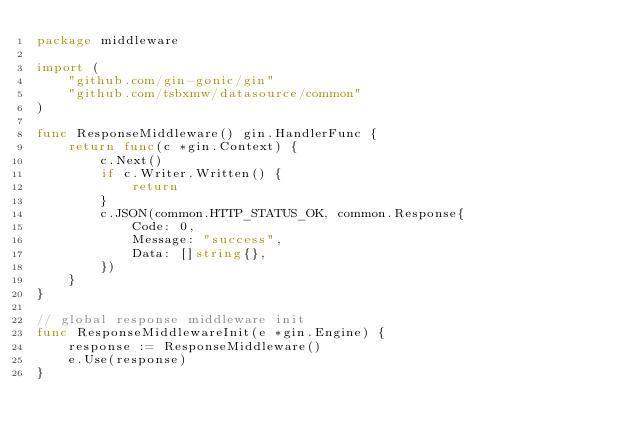Convert code to text. <code><loc_0><loc_0><loc_500><loc_500><_Go_>package middleware

import (
    "github.com/gin-gonic/gin"
    "github.com/tsbxmw/datasource/common"
)

func ResponseMiddleware() gin.HandlerFunc {
    return func(c *gin.Context) {
        c.Next()
        if c.Writer.Written() {
            return
        }
        c.JSON(common.HTTP_STATUS_OK, common.Response{
            Code: 0,
            Message: "success",
            Data: []string{},
        })
    }
}

// global response middleware init
func ResponseMiddlewareInit(e *gin.Engine) {
    response := ResponseMiddleware()
    e.Use(response)
}
</code> 